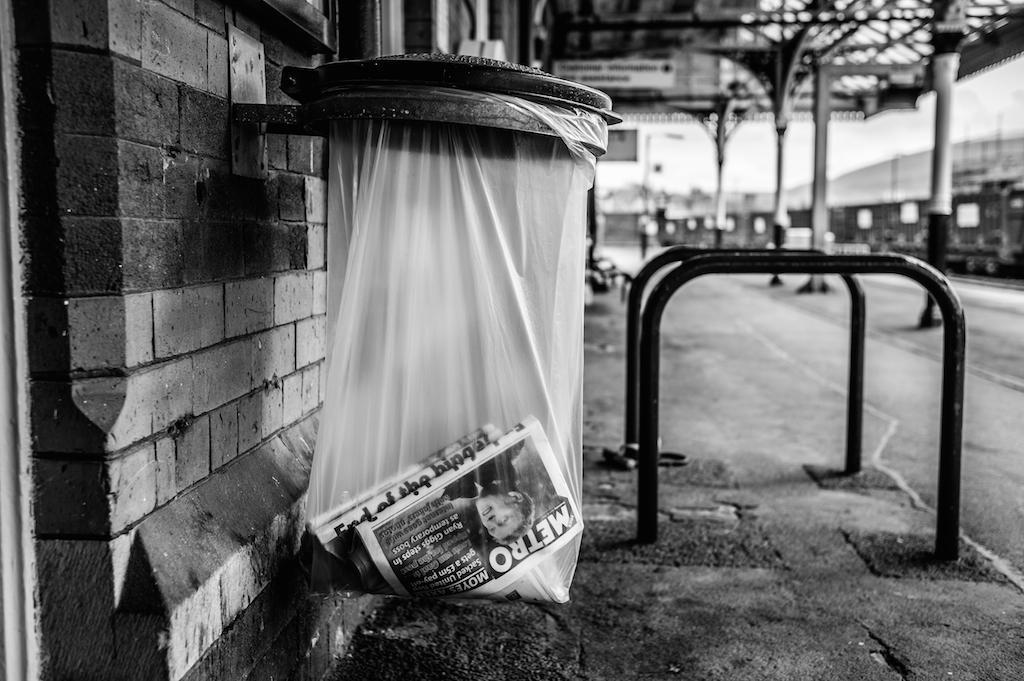Provide a one-sentence caption for the provided image. A plastic bag hanging on the side of a street contains a Metro newspaper. 